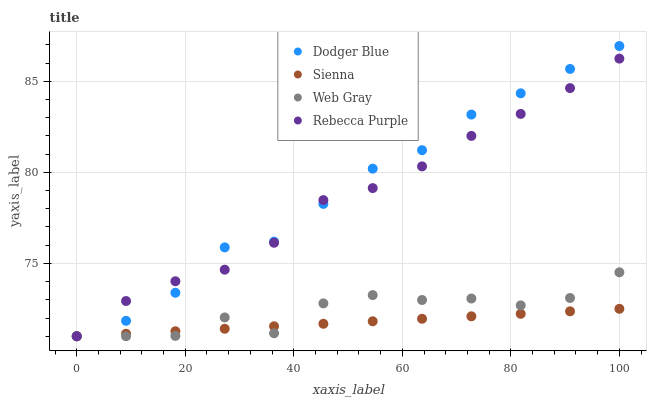Does Sienna have the minimum area under the curve?
Answer yes or no. Yes. Does Dodger Blue have the maximum area under the curve?
Answer yes or no. Yes. Does Web Gray have the minimum area under the curve?
Answer yes or no. No. Does Web Gray have the maximum area under the curve?
Answer yes or no. No. Is Sienna the smoothest?
Answer yes or no. Yes. Is Web Gray the roughest?
Answer yes or no. Yes. Is Dodger Blue the smoothest?
Answer yes or no. No. Is Dodger Blue the roughest?
Answer yes or no. No. Does Sienna have the lowest value?
Answer yes or no. Yes. Does Dodger Blue have the highest value?
Answer yes or no. Yes. Does Web Gray have the highest value?
Answer yes or no. No. Does Dodger Blue intersect Sienna?
Answer yes or no. Yes. Is Dodger Blue less than Sienna?
Answer yes or no. No. Is Dodger Blue greater than Sienna?
Answer yes or no. No. 